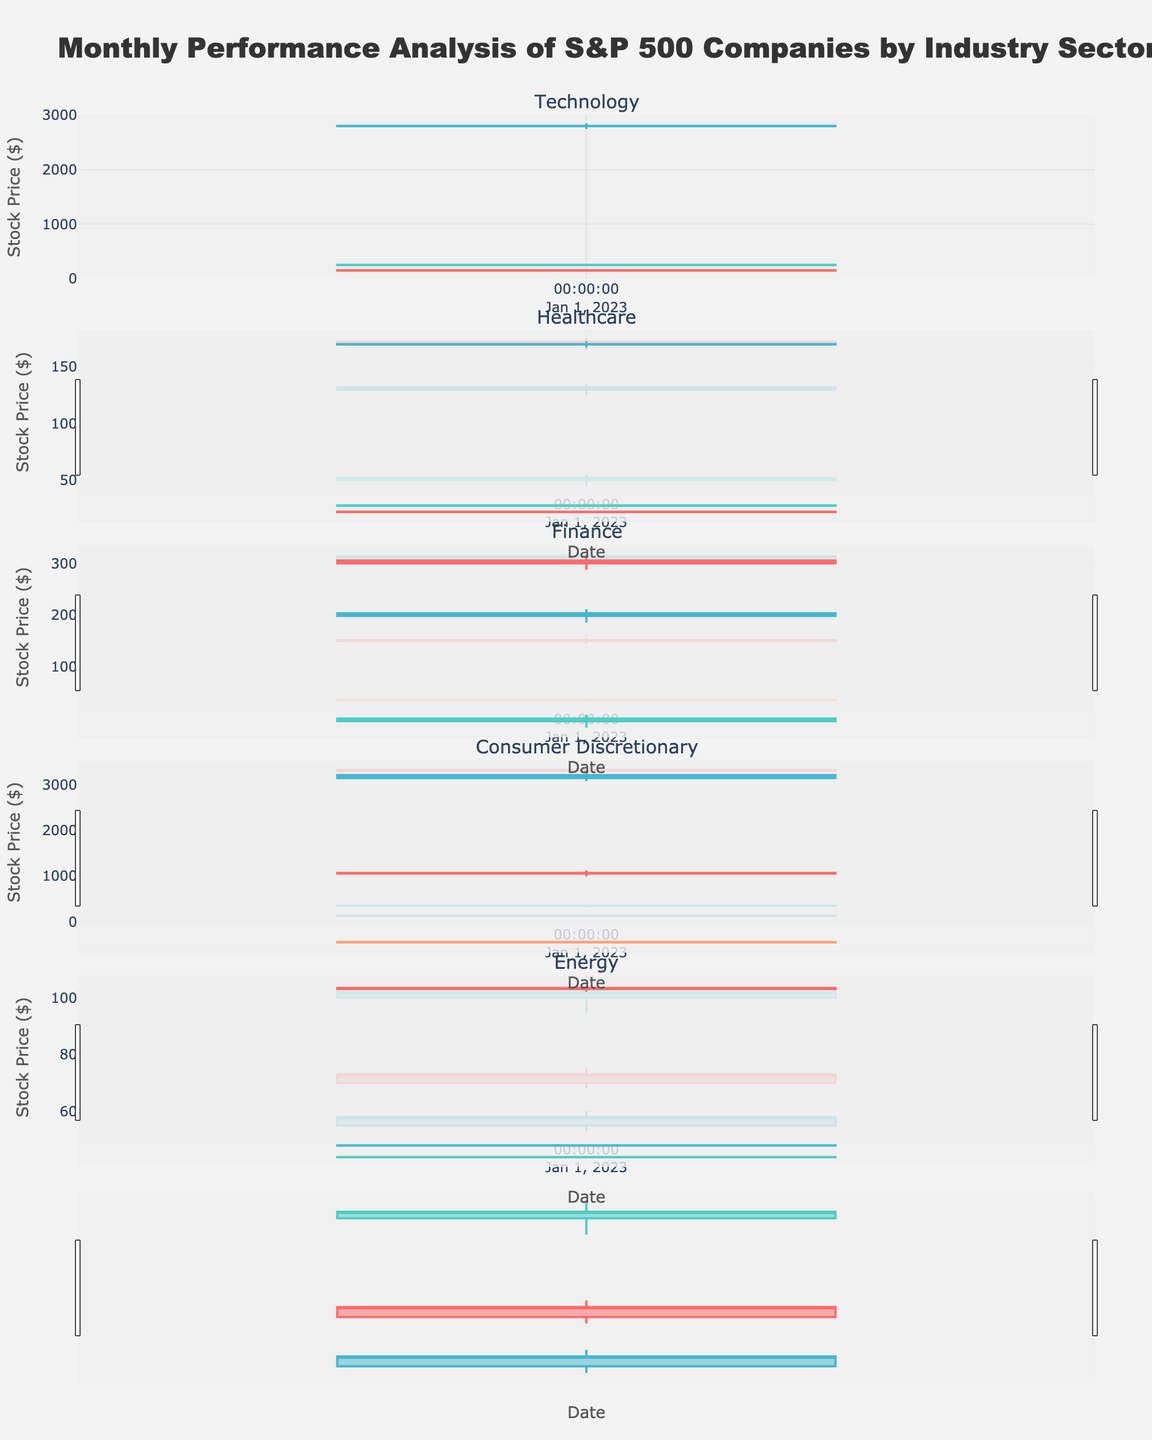Which company has the highest closing price in the Technology sector? In the Technology sector, the closing prices for companies are: Apple (155.00), Microsoft (255.00), and Google (2805.00). The highest closing price is for Google.
Answer: Google How many companies are included in the Healthcare sector? The Healthcare sector includes the following companies: Johnson & Johnson, Pfizer, and Moderna. This gives us a total of 3 companies.
Answer: 3 Which sector has the least variation in the highest and lowest prices? We need to calculate the variation (difference between the highest and lowest prices) for each sector: Technology (Google: 2850.00 - 2750.00 = 100.00), Healthcare (Pfizer: 55.00 - 45.00 = 10.00), Finance (Goldman Sachs: 320.00 - 305.00 = 15.00), Consumer Discretionary (Nike: 135.00 - 125.00 = 10.00), Energy (ConocoPhillips: 60.00 - 53.00 = 7.00). The smallest variation is in the Energy sector.
Answer: Energy Which company in the Finance sector had the lowest closing price? In the Finance sector, the closing prices for companies are: JPMorgan Chase (151.00), Bank of America (34.50), Goldman Sachs (315.00). Bank of America has the lowest closing price.
Answer: Bank of America In which month is the data presented in the figure? The 'Date' column in the data has the same value "2023-01-01" for all entries, indicating that the data is for January 2023.
Answer: January 2023 Did any company's stock close at its highest price of the month? A company would need its close price to be equal to its high price. Reviewing the data, none of the companies have their closing price equal to their highest price.
Answer: No Which company in the Energy sector saw the greatest increase from open to close prices? The increase can be calculated as (Close - Open): ExxonMobil (73.00 - 70.00 = 3.00), Chevron (102.00 - 100.00 = 2.00), ConocoPhillips (58.00 - 55.00 = 3.00). ExxonMobil and ConocoPhillips each had an increase of 3.00.
Answer: ExxonMobil and ConocoPhillips Which sector had the highest average closing price? Calculate the average closing price for each sector: Technology ((155.00 + 255.00 + 2805.00)/3 = 1071.67), Healthcare ((172.00 + 52.00 + 132.00)/3 = 118.67), Finance ((151.00 + 34.50 + 315.00)/3 = 166.17), Consumer Discretionary ((3320.00 + 132.00 + 352.00)/3 = 1268.00), Energy ((73.00 + 102.00 + 58.00)/3 = 77.67). The Consumer Discretionary sector has the highest average closing price.
Answer: Consumer Discretionary Which company had the highest volatility (difference between high and low prices)? Calculating the difference for each company: Apple (160.00 - 145.00 = 15.00), Microsoft (260.00 - 245.00 = 15.00), Google (2850.00 - 2750.00 = 100.00), Johnson & Johnson (175.00 - 165.00 = 10.00), Pfizer (55.00 - 45.00 = 10.00), Moderna (135.00 - 125.00 = 10.00), JPMorgan Chase (155.00 - 145.00 = 10.00), Bank of America (36.50 - 33.00 = 3.50), Goldman Sachs (320.00 - 305.00 = 15.00), Amazon (3350.00 - 3250.00 = 100.00), Nike (135.00 - 125.00 = 10.00), Home Depot (355.00 - 345.00 = 10.00), ExxonMobil (75.00 - 68.00 = 7.00), Chevron (105.00 - 95.00 = 10.00), ConocoPhillips (60.00 - 53.00 = 7.00). Google and Amazon both have the highest volatility of 100.00.
Answer: Google and Amazon 